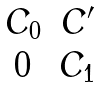Convert formula to latex. <formula><loc_0><loc_0><loc_500><loc_500>\begin{matrix} C _ { 0 } & C ^ { \prime } \\ 0 & C _ { 1 } \end{matrix}</formula> 